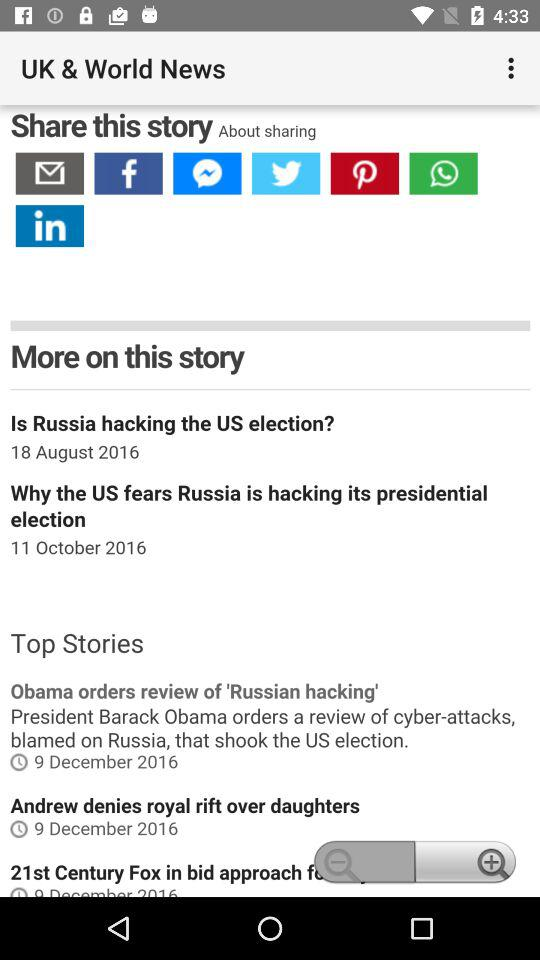How many stories are there in the top stories section?
Answer the question using a single word or phrase. 3 